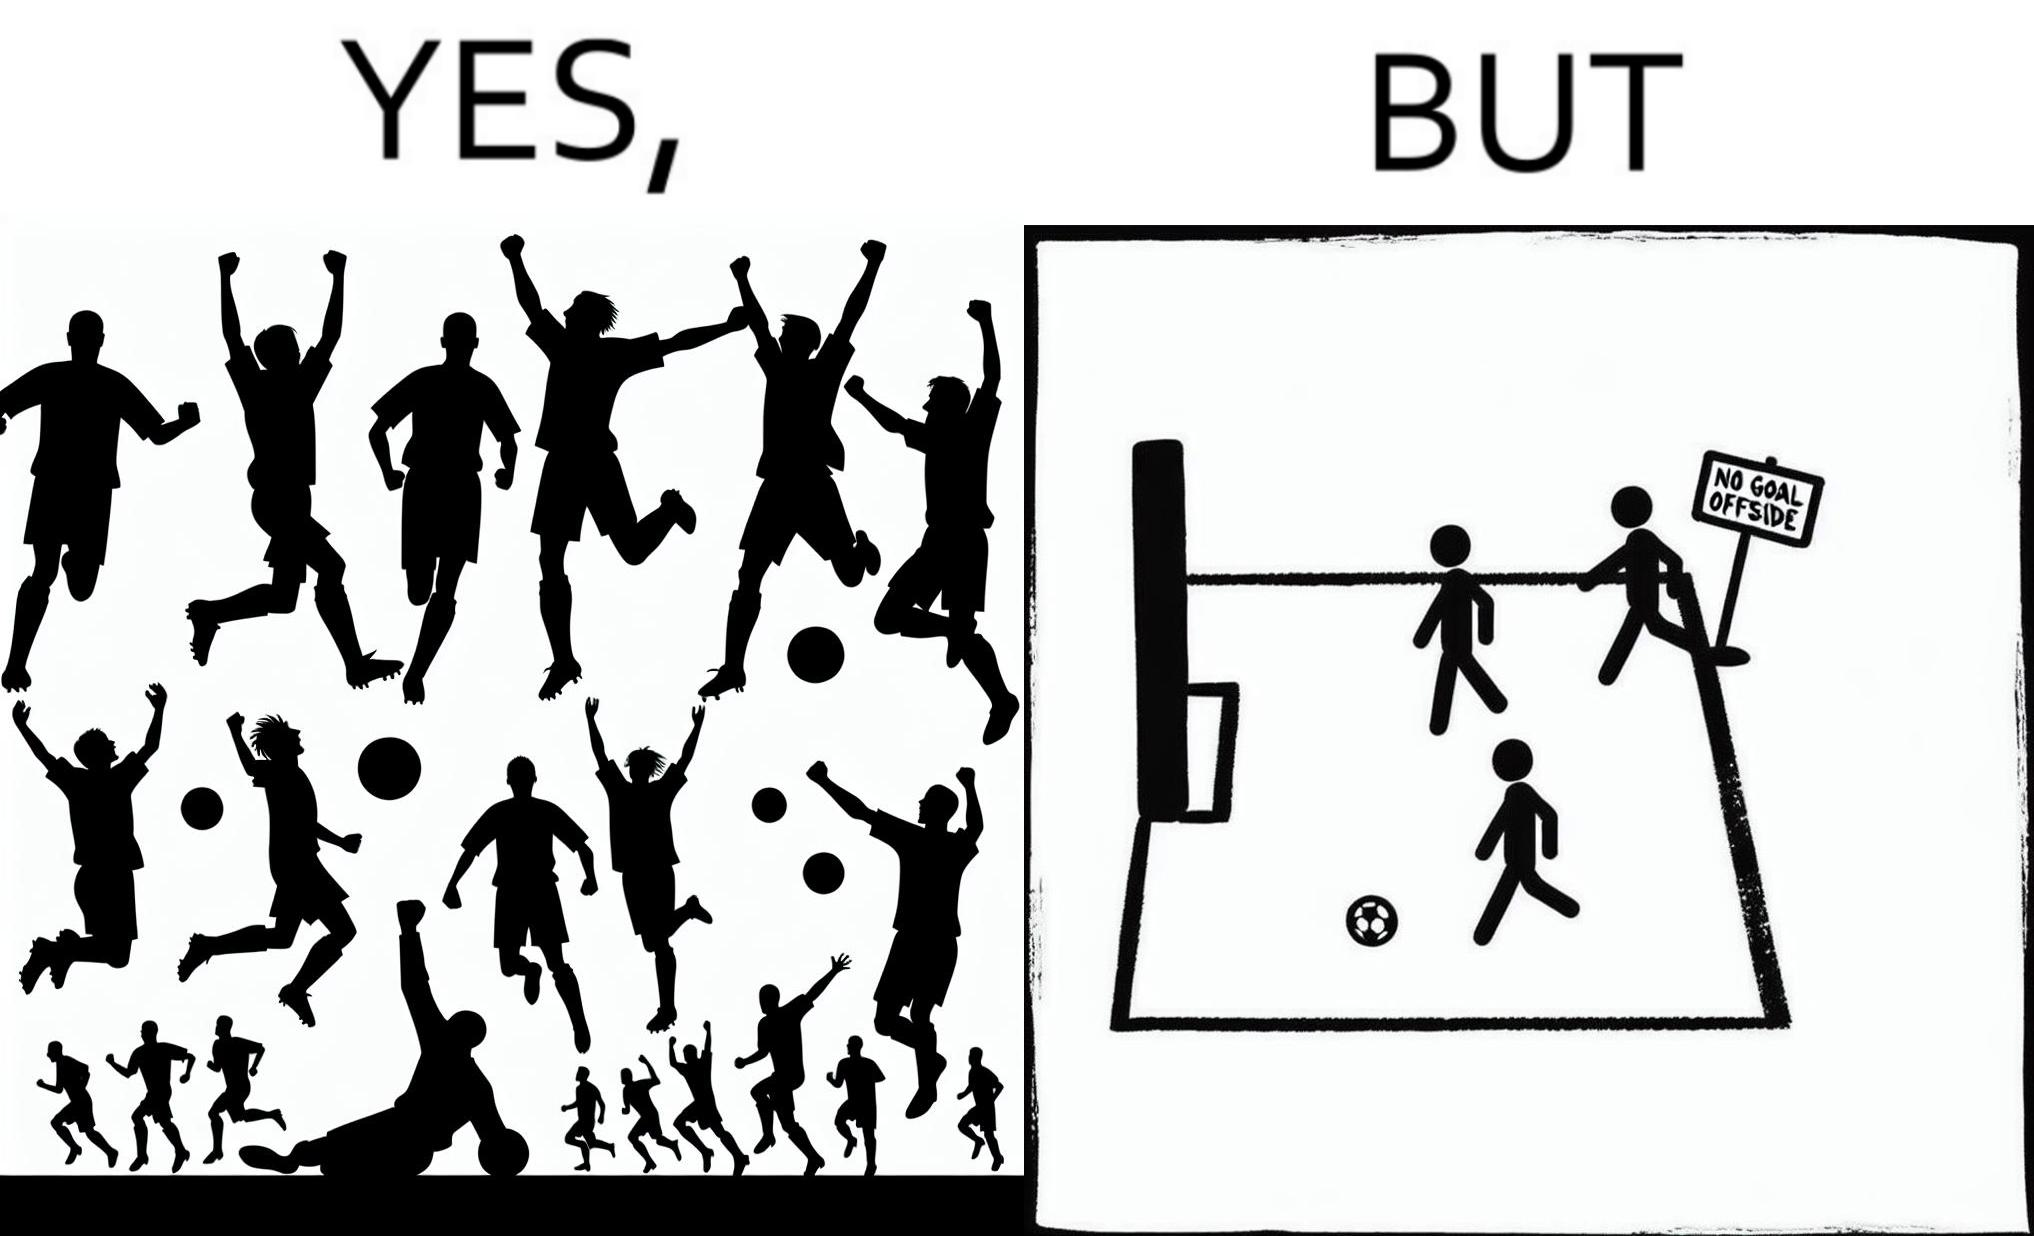Describe the content of this image. The image is ironical, as the team is celebrating as they think that they have scored a goal, but the sign on the screen says that it is an offside, and not a goal. This is a very common scenario in football matches. 